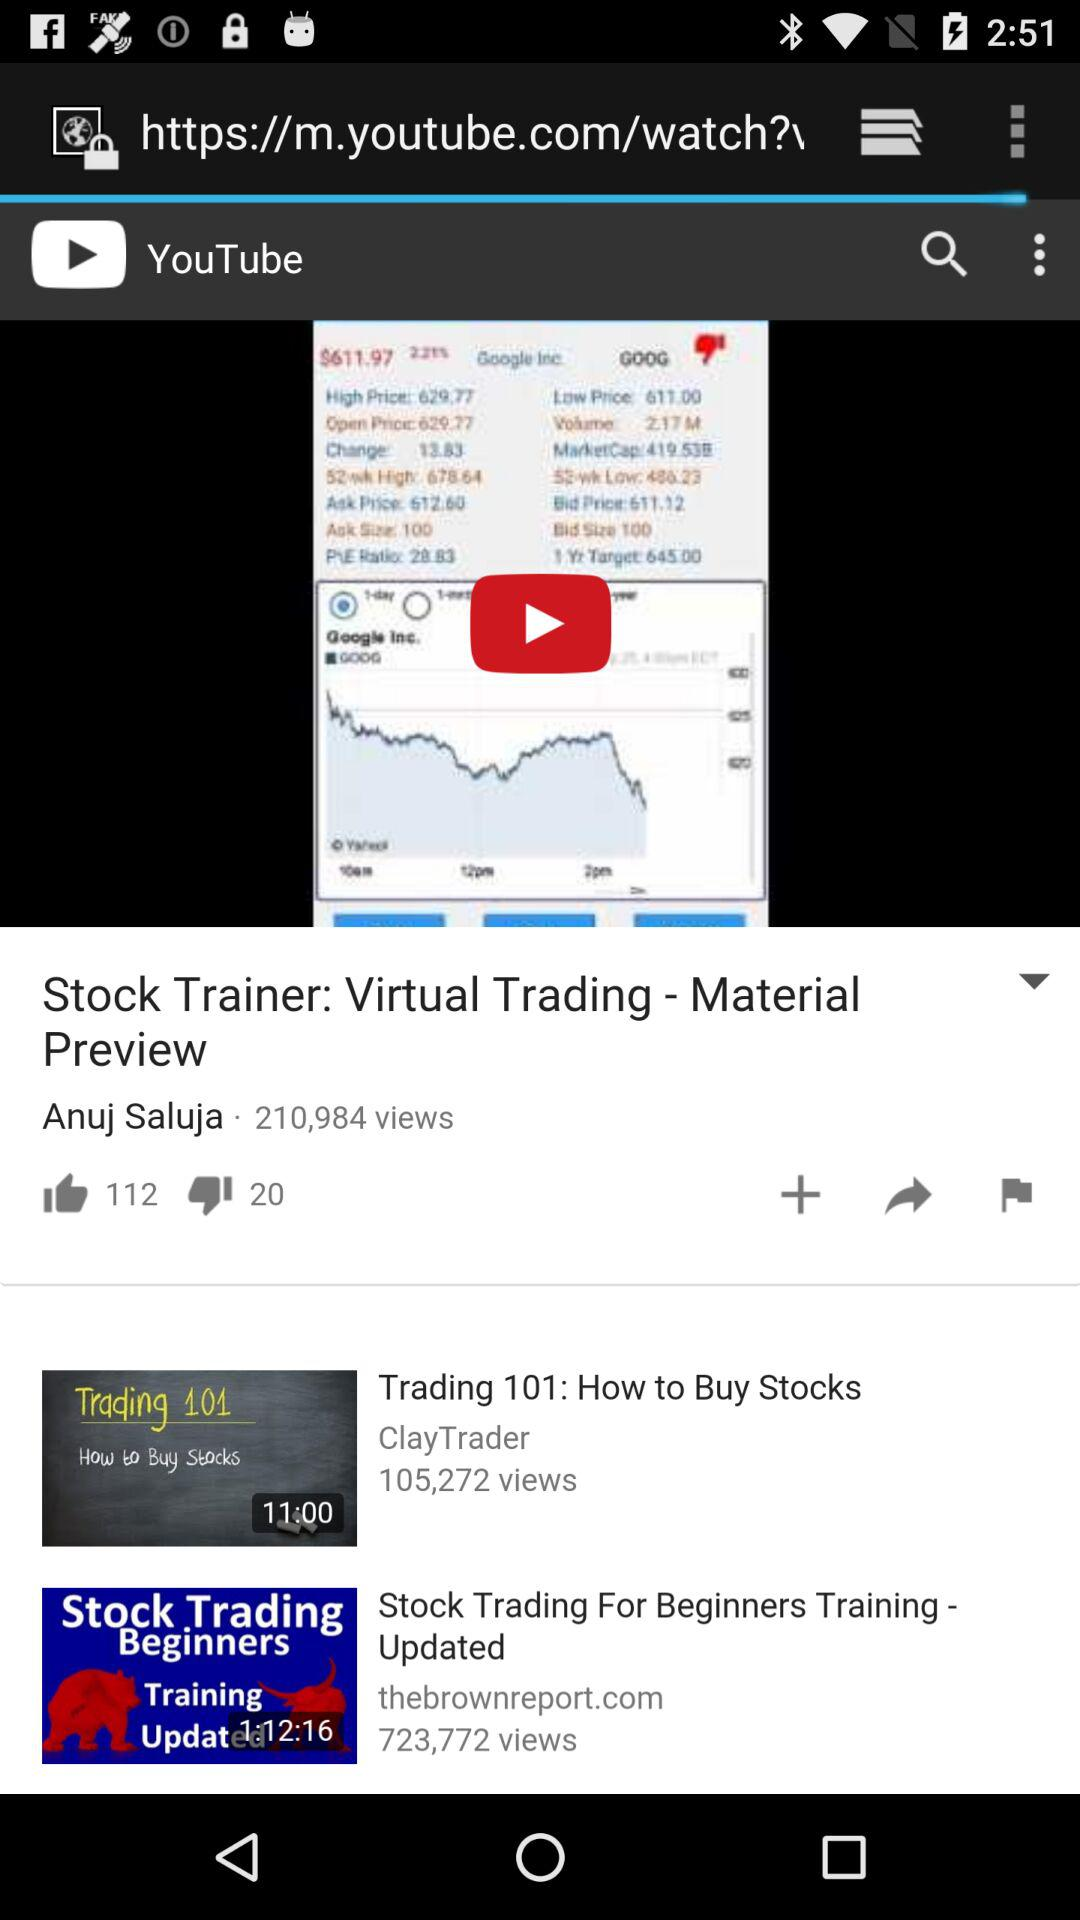How many more thumbs up than down does the video have?
Answer the question using a single word or phrase. 92 